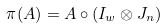Convert formula to latex. <formula><loc_0><loc_0><loc_500><loc_500>\pi ( A ) = A \circ ( I _ { w } \otimes J _ { n } )</formula> 